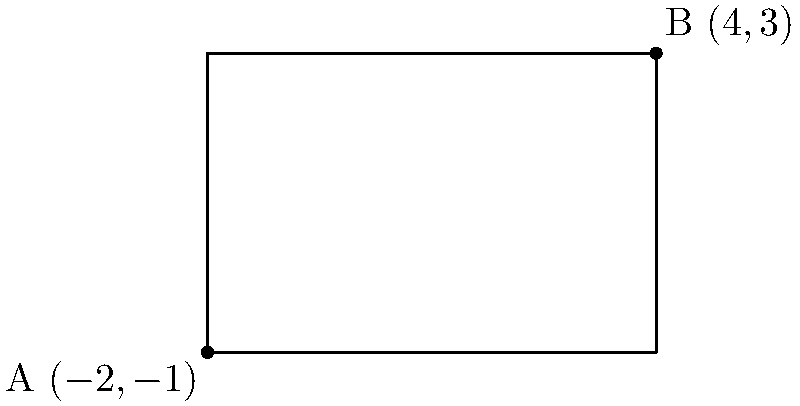In honor of Daniel Chacón's love for geometric storytelling, imagine a rectangular plot of land in his fictional universe. The opposite corners of this rectangle are represented by points A$(-2,-1)$ and B$(4,3)$ on a coordinate plane. Calculate the area of this rectangular plot. To find the area of the rectangle, we need to calculate its length and width:

1. Calculate the width (change in x-coordinate):
   $\text{Width} = |x_B - x_A| = |4 - (-2)| = |4 + 2| = 6$

2. Calculate the height (change in y-coordinate):
   $\text{Height} = |y_B - y_A| = |3 - (-1)| = |3 + 1| = 4$

3. Calculate the area using the formula: $\text{Area} = \text{Width} \times \text{Height}$
   $\text{Area} = 6 \times 4 = 24$

Therefore, the area of the rectangular plot is 24 square units.
Answer: 24 square units 